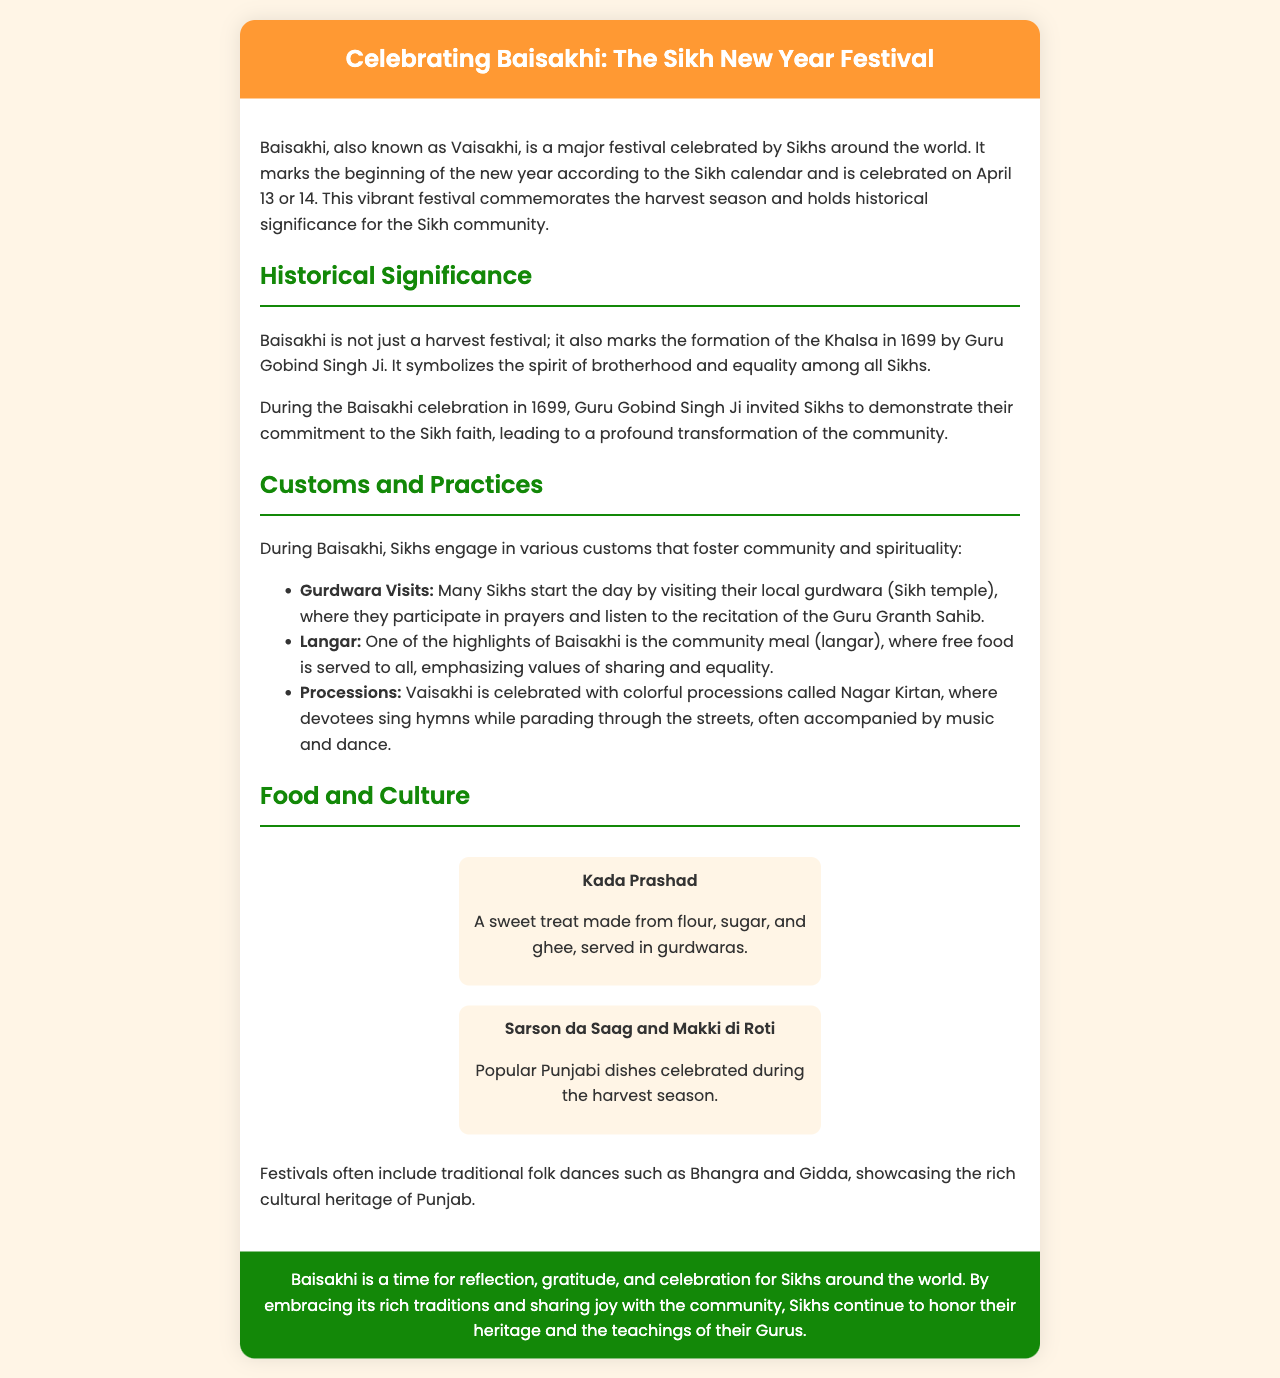What is Baisakhi also known as? Baisakhi is also known as Vaisakhi, as mentioned in the introductory paragraph.
Answer: Vaisakhi When is Baisakhi celebrated? Baisakhi is celebrated on April 13 or 14, as stated in the document.
Answer: April 13 or 14 What significant event does Baisakhi commemorate? The event that Baisakhi commemorates is the formation of the Khalsa in 1699 by Guru Gobind Singh Ji.
Answer: Formation of the Khalsa What is the importance of Langar during Baisakhi? Langar emphasizes values of sharing and equality, as indicated in the customs section.
Answer: Sharing and equality What are the two popular food items mentioned for Baisakhi? The document lists Kada Prashad and Sarson da Saag and Makki di Roti as notable food items.
Answer: Kada Prashad and Sarson da Saag and Makki di Roti What type of dance is celebrated during Baisakhi? Festivals include traditional folk dances such as Bhangra and Gidda, as mentioned in the food and culture section.
Answer: Bhangra and Gidda What does Baisakhi symbolize for the Sikh community? Baisakhi symbolizes the spirit of brotherhood and equality among all Sikhs, as noted in the historical significance section.
Answer: Brotherhood and equality What is the main activity that many Sikhs participate in on Baisakhi morning? Many Sikhs start the day by visiting their local gurdwara, as stated under customs and practices.
Answer: Visiting gurdwara What kind of processions are part of Baisakhi celebrations? The celebrations involve colorful processions called Nagar Kirtan, according to the customs and practices section.
Answer: Nagar Kirtan 